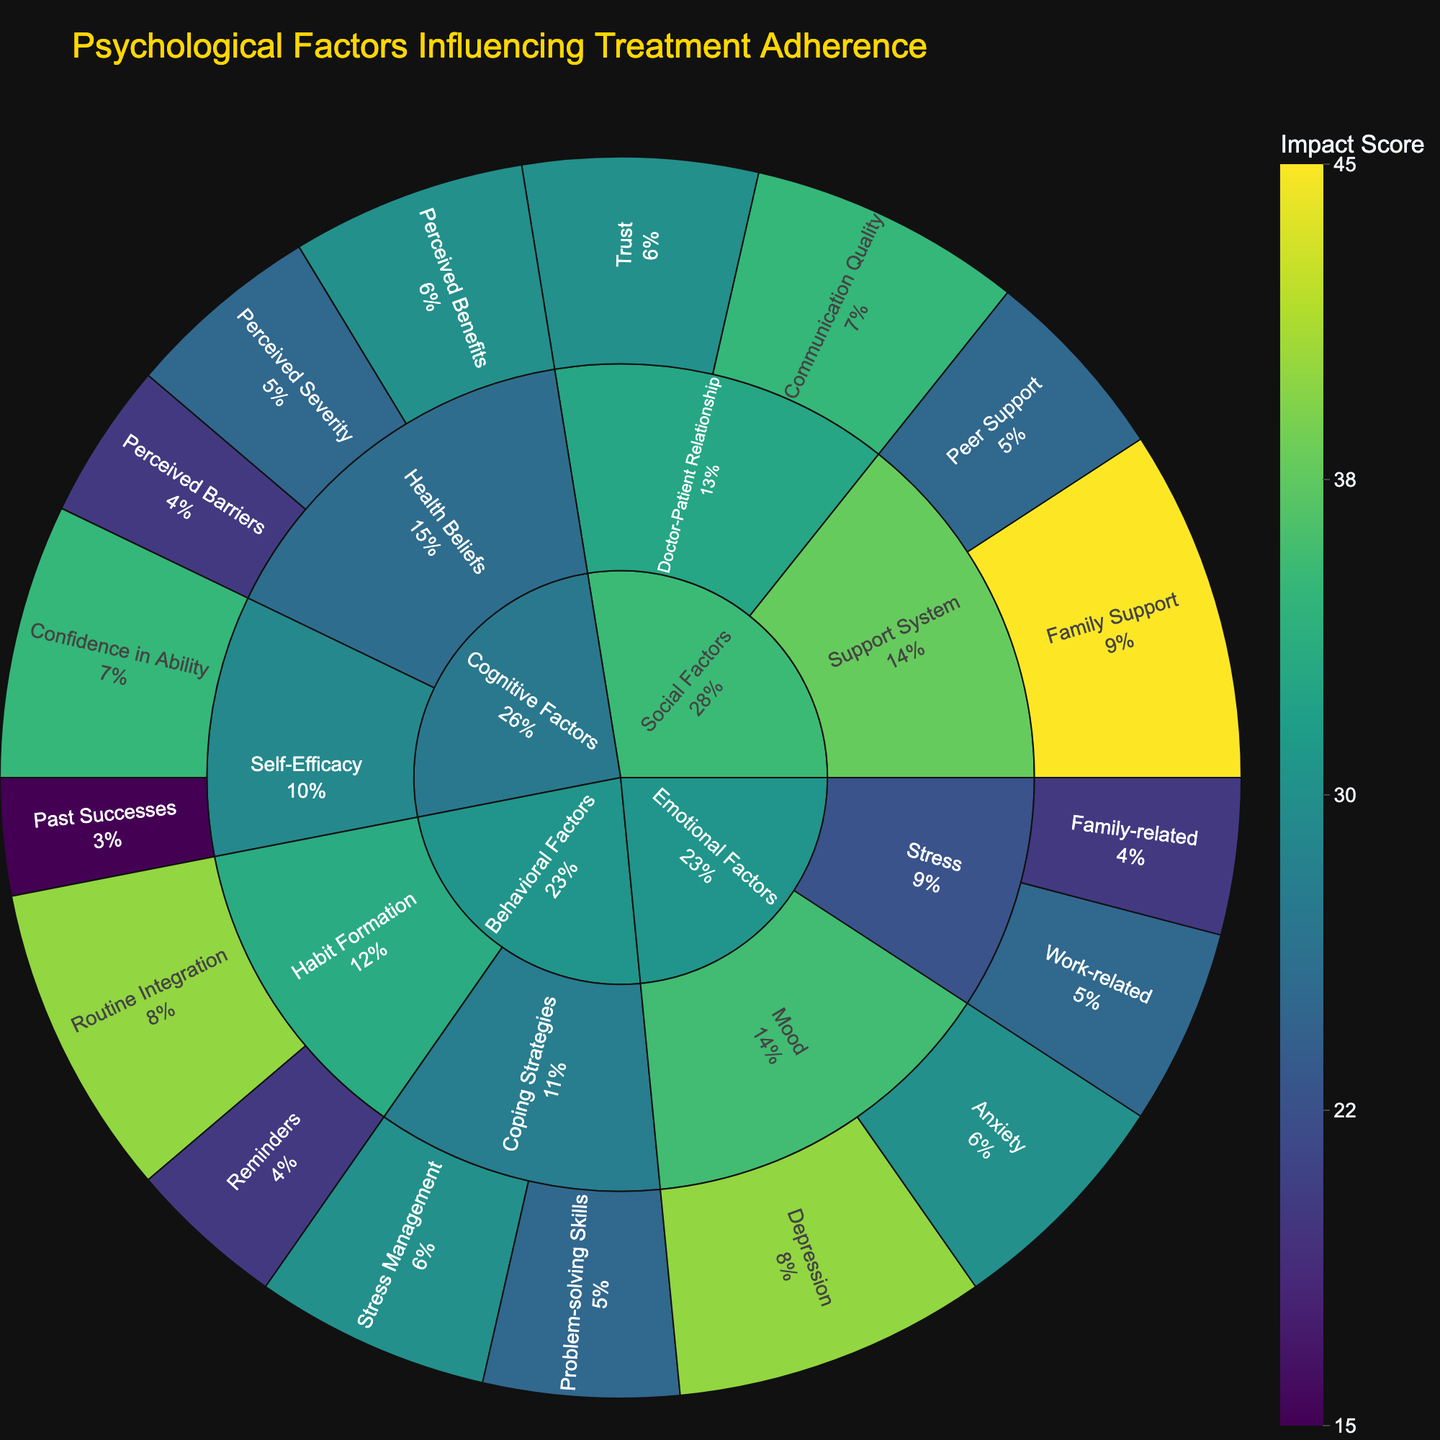What's the title of the figure? The title of the figure is usually displayed prominently at the top. By looking at the top of the Sunburst Plot, you can find it written in a larger and bolded font.
Answer: Psychological Factors Influencing Treatment Adherence What factor has the highest impact score under Emotional Factors? To find the factor with the highest impact score under "Emotional Factors", first identify subcategories within "Emotional Factors" and then look for the highest value among those factors.
Answer: Depression How does Peer Support compare to Family Support in terms of impact score? Peer Support and Family Support are subcategories within the Social Factors. By looking at their respective scores, you can see that Peer Support has a score of 25 and Family Support has a score of 45.
Answer: Family Support is higher What is the combined impact score of all Health Beliefs factors? The three factors under Health Beliefs are Perceived Severity (25), Perceived Benefits (30), and Perceived Barriers (20). Summing these scores gives 25 + 30 + 20.
Answer: 75 What is the average impact score of factors within Self-Efficacy? The factors within Self-Efficacy are Confidence in Ability (35) and Past Successes (15). The average is calculated by summing these values and dividing by the number of factors, (35 + 15)/2.
Answer: 25 Which factor within Behavioral Factors has the lowest impact score? Within Behavioral Factors, identify scores for Routine Integration, Reminders, Problem-solving Skills, and Stress Management. The lowest score among these factors is 20 for Reminders.
Answer: Reminders What's the difference in impact scores between Routine Integration and Stress Management? Routine Integration and Stress Management are both under Behavioral Factors with scores 40 and 30 respectively. The difference is calculated as 40 - 30.
Answer: 10 What percentage of the impact does Doctor-Patient Relationship contribute to Social Factors? First, find the scores of all factors under Social Factors and sum them. For Doctor-Patient Relationship (Communication Quality 35 and Trust 30), calculate the proportion of this sum and convert to percentage. Total for Social Factors is 45+25+35+30=135; Doctor-Patient Relationship total is 35+30=65. The percentage is (65/135) * 100.
Answer: 48.15% Which category has the greatest overall impact? Sum the values of each category: Cognitive Factors (125), Emotional Factors (115), Social Factors (135), and Behavioral Factors (115). By comparing these sums, Social Factors has the highest sum.
Answer: Social Factors 